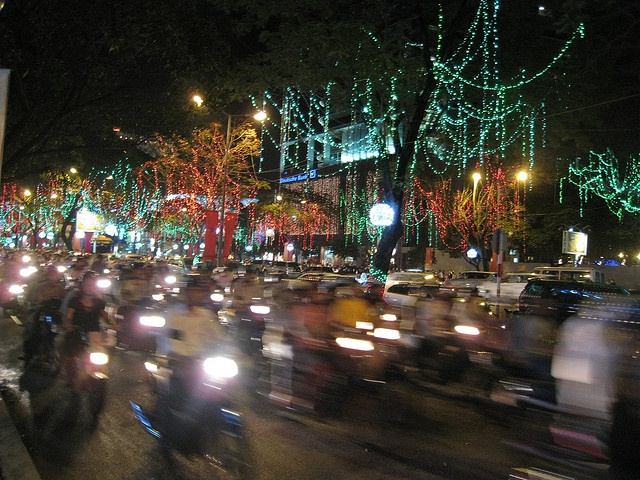Describe the objects in this image and their specific colors. I can see motorcycle in black, gray, and white tones, people in black, gray, and darkgray tones, people in black and gray tones, motorcycle in black, maroon, white, and brown tones, and people in black and gray tones in this image. 